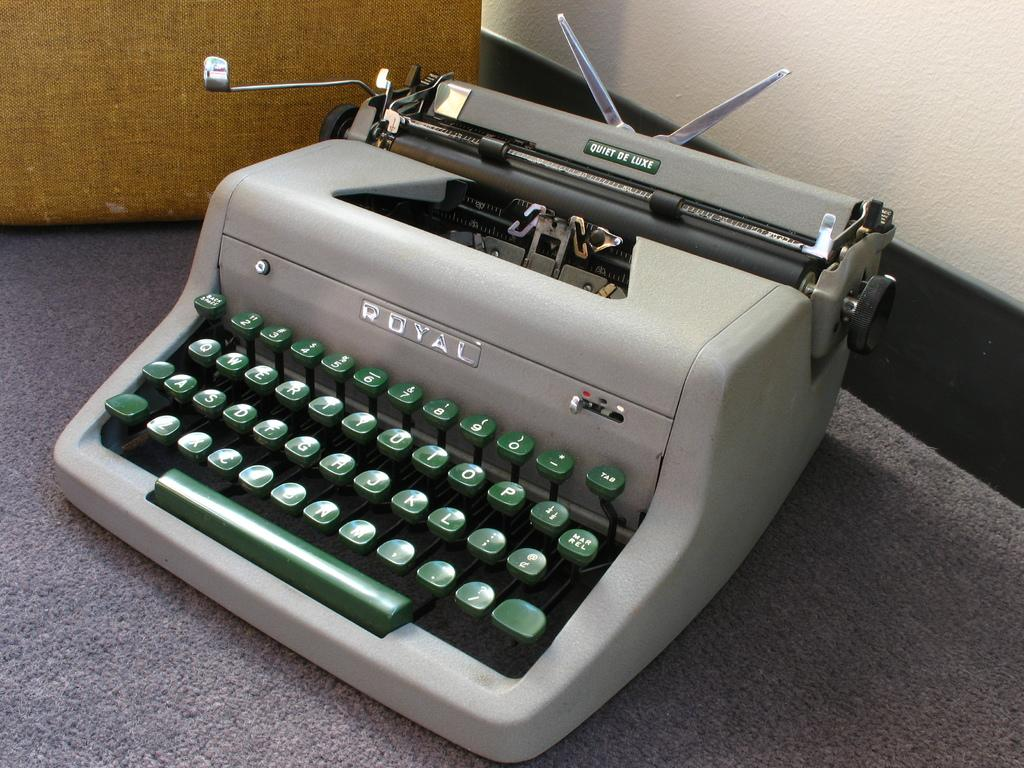<image>
Summarize the visual content of the image. Gray and green typewriter with the word ROYAL on the top. 